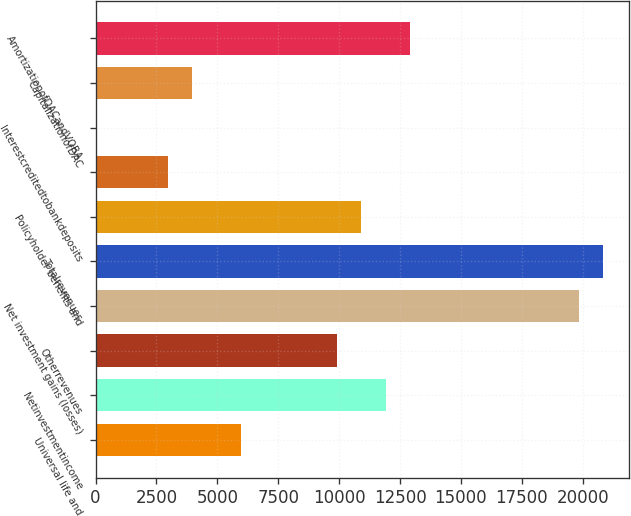Convert chart. <chart><loc_0><loc_0><loc_500><loc_500><bar_chart><fcel>Universal life and<fcel>Netinvestmentincome<fcel>Otherrevenues<fcel>Net investment gains (losses)<fcel>Totalrevenues<fcel>Policyholder benefits and<fcel>Unnamed: 6<fcel>Interestcreditedtobankdeposits<fcel>CapitalizationofDAC<fcel>AmortizationofDACandVOBA<nl><fcel>5956.8<fcel>11910.6<fcel>9926<fcel>19849<fcel>20841.3<fcel>10918.3<fcel>2979.9<fcel>3<fcel>3972.2<fcel>12902.9<nl></chart> 